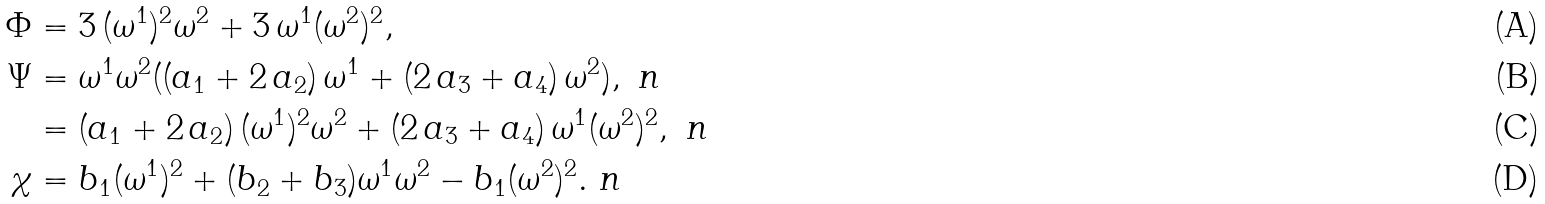Convert formula to latex. <formula><loc_0><loc_0><loc_500><loc_500>\Phi & = 3 \, ( \omega ^ { 1 } ) ^ { 2 } \omega ^ { 2 } + 3 \, \omega ^ { 1 } ( \omega ^ { 2 } ) ^ { 2 } , \\ \Psi & = \omega ^ { 1 } \omega ^ { 2 } ( ( a _ { 1 } + 2 \, a _ { 2 } ) \, \omega ^ { 1 } + ( 2 \, a _ { 3 } + a _ { 4 } ) \, \omega ^ { 2 } ) , \ n \\ & = ( a _ { 1 } + 2 \, a _ { 2 } ) \, ( \omega ^ { 1 } ) ^ { 2 } \omega ^ { 2 } + ( 2 \, a _ { 3 } + a _ { 4 } ) \, \omega ^ { 1 } ( \omega ^ { 2 } ) ^ { 2 } , \ n \\ \chi & = b _ { 1 } ( \omega ^ { 1 } ) ^ { 2 } + ( b _ { 2 } + b _ { 3 } ) \omega ^ { 1 } \omega ^ { 2 } - b _ { 1 } ( \omega ^ { 2 } ) ^ { 2 } . \ n</formula> 